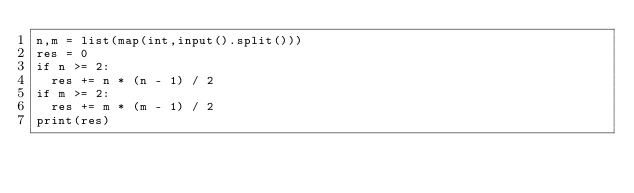Convert code to text. <code><loc_0><loc_0><loc_500><loc_500><_Python_>n,m = list(map(int,input().split()))
res = 0
if n >= 2:
  res += n * (n - 1) / 2
if m >= 2:
  res += m * (m - 1) / 2
print(res)</code> 